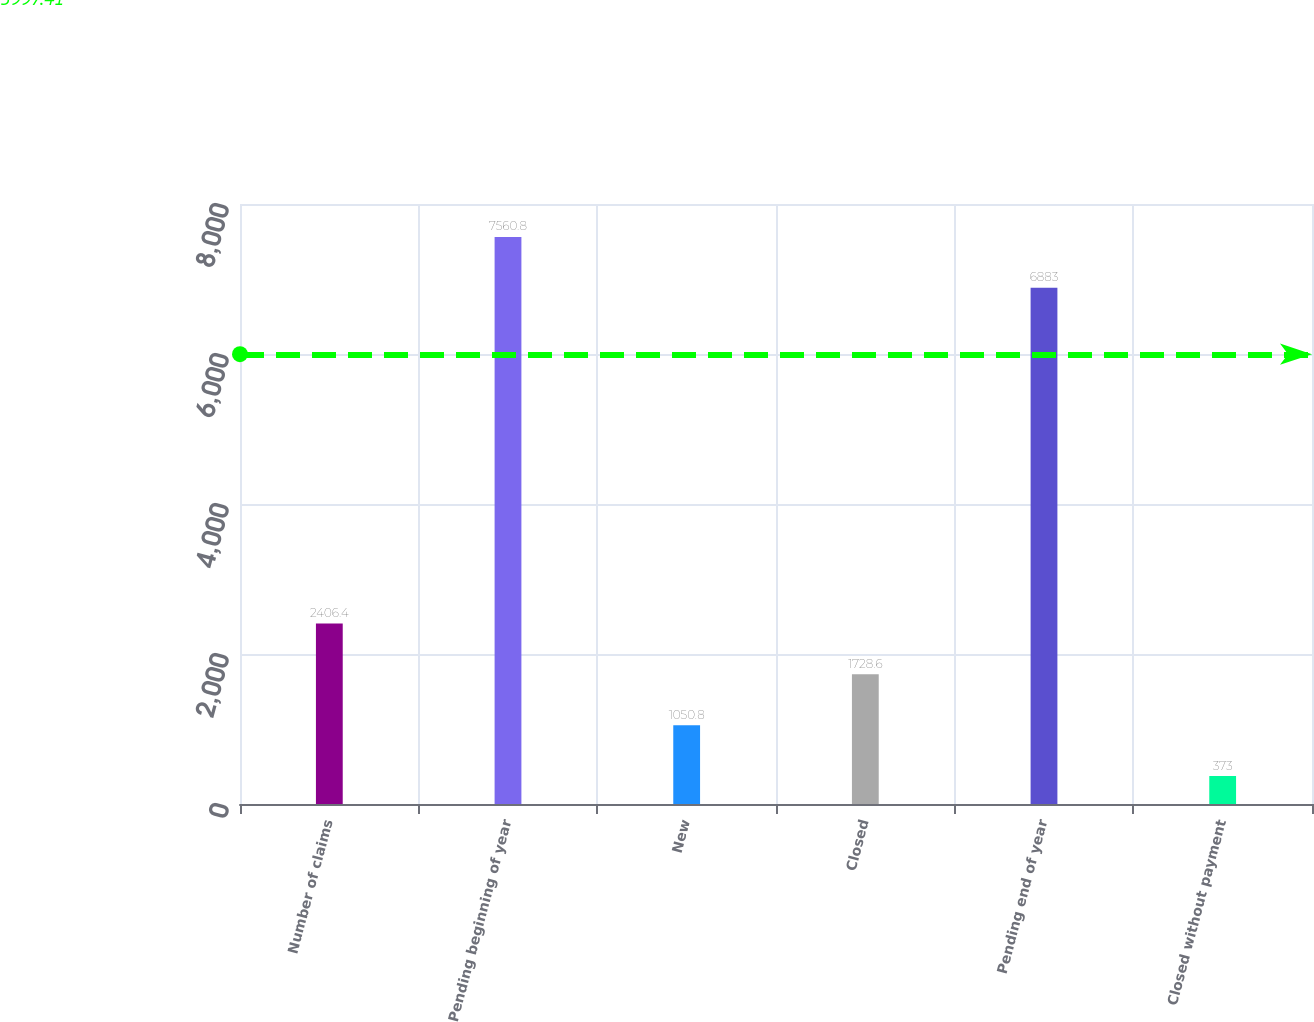Convert chart to OTSL. <chart><loc_0><loc_0><loc_500><loc_500><bar_chart><fcel>Number of claims<fcel>Pending beginning of year<fcel>New<fcel>Closed<fcel>Pending end of year<fcel>Closed without payment<nl><fcel>2406.4<fcel>7560.8<fcel>1050.8<fcel>1728.6<fcel>6883<fcel>373<nl></chart> 